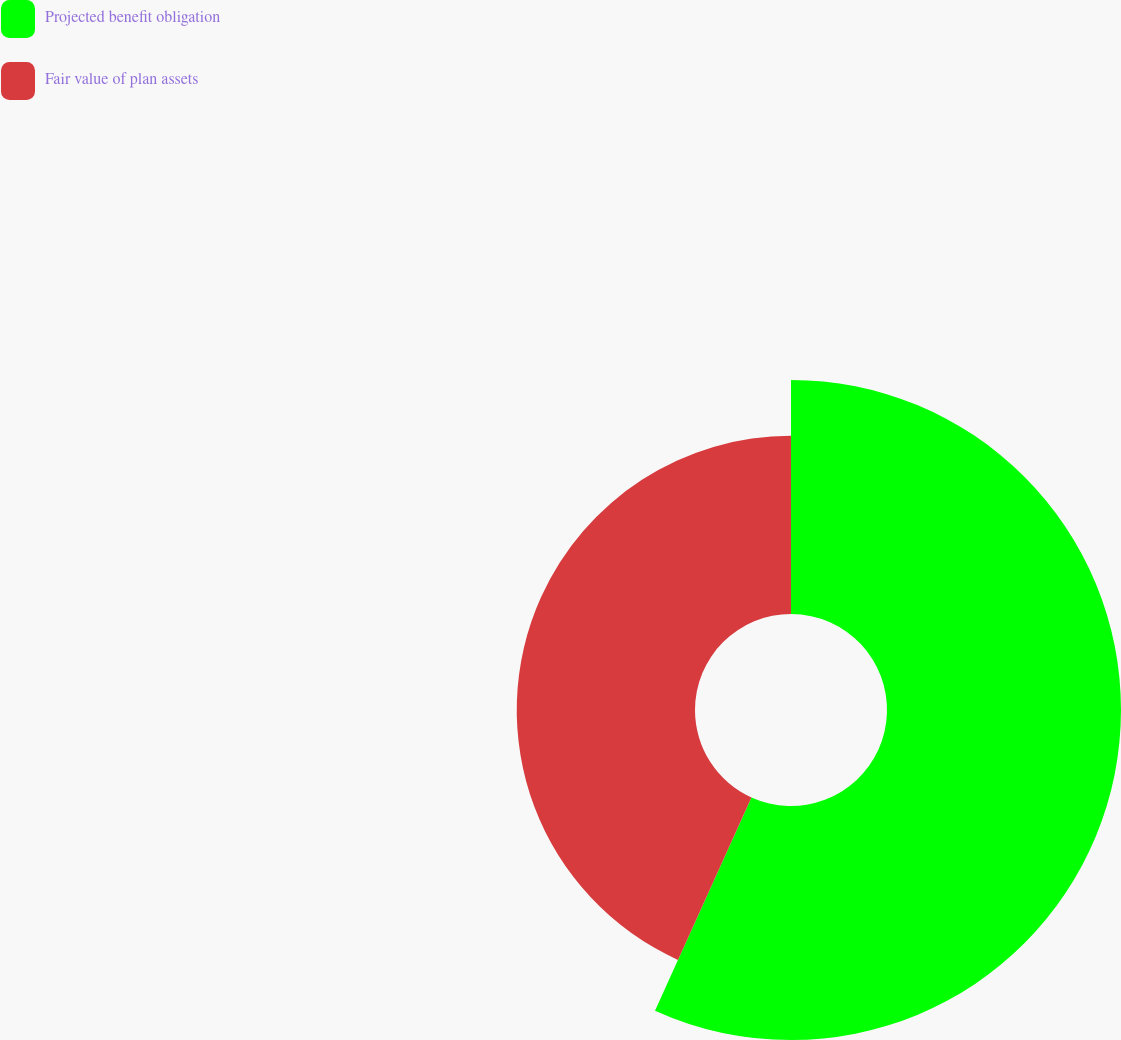Convert chart. <chart><loc_0><loc_0><loc_500><loc_500><pie_chart><fcel>Projected benefit obligation<fcel>Fair value of plan assets<nl><fcel>56.76%<fcel>43.24%<nl></chart> 